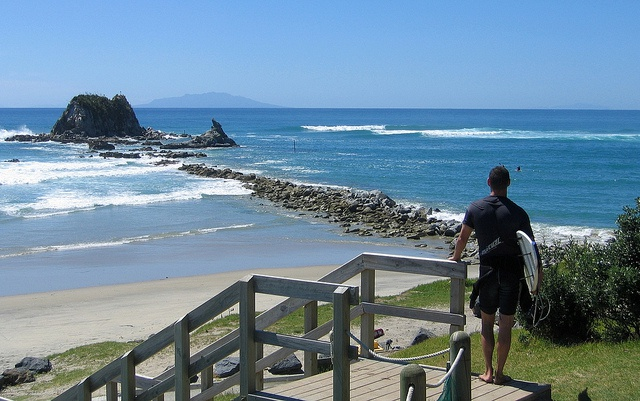Describe the objects in this image and their specific colors. I can see people in lightblue, black, gray, darkgreen, and darkgray tones, surfboard in lightblue, black, gray, and darkgray tones, and people in lightblue, navy, teal, gray, and black tones in this image. 